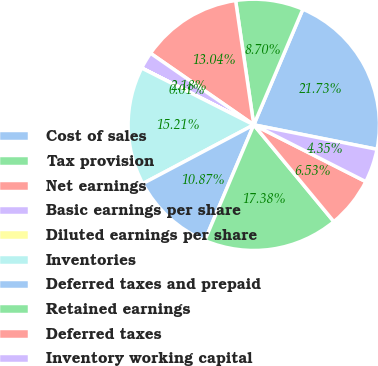<chart> <loc_0><loc_0><loc_500><loc_500><pie_chart><fcel>Cost of sales<fcel>Tax provision<fcel>Net earnings<fcel>Basic earnings per share<fcel>Diluted earnings per share<fcel>Inventories<fcel>Deferred taxes and prepaid<fcel>Retained earnings<fcel>Deferred taxes<fcel>Inventory working capital<nl><fcel>21.73%<fcel>8.7%<fcel>13.04%<fcel>2.18%<fcel>0.01%<fcel>15.21%<fcel>10.87%<fcel>17.38%<fcel>6.53%<fcel>4.35%<nl></chart> 